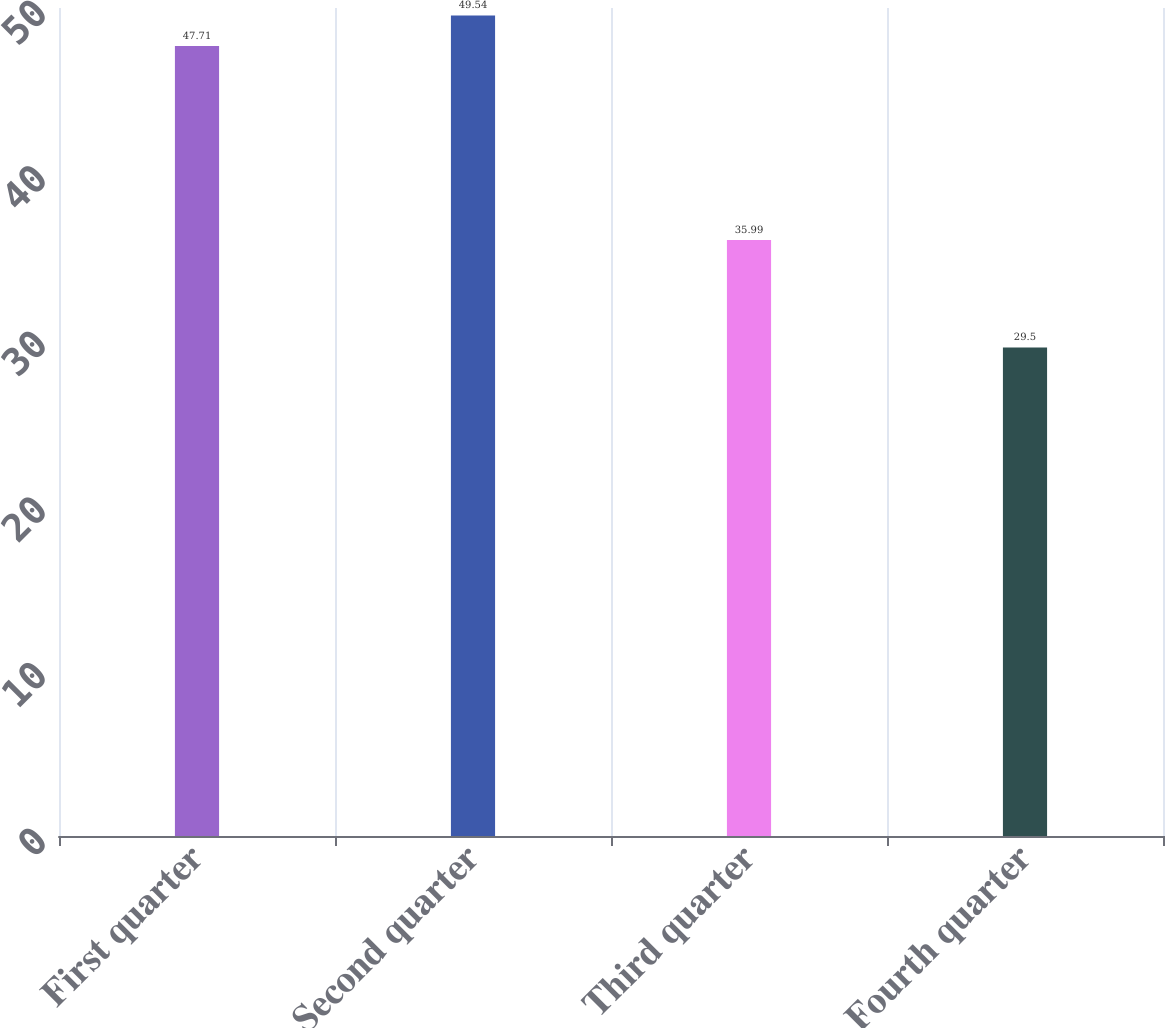<chart> <loc_0><loc_0><loc_500><loc_500><bar_chart><fcel>First quarter<fcel>Second quarter<fcel>Third quarter<fcel>Fourth quarter<nl><fcel>47.71<fcel>49.54<fcel>35.99<fcel>29.5<nl></chart> 